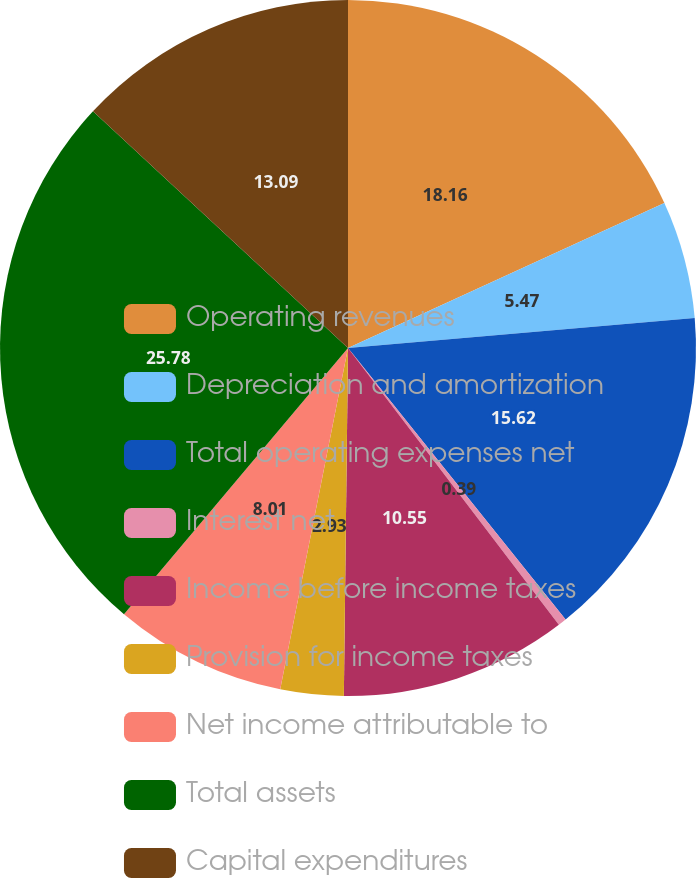Convert chart. <chart><loc_0><loc_0><loc_500><loc_500><pie_chart><fcel>Operating revenues<fcel>Depreciation and amortization<fcel>Total operating expenses net<fcel>Interest net<fcel>Income before income taxes<fcel>Provision for income taxes<fcel>Net income attributable to<fcel>Total assets<fcel>Capital expenditures<nl><fcel>18.16%<fcel>5.47%<fcel>15.62%<fcel>0.39%<fcel>10.55%<fcel>2.93%<fcel>8.01%<fcel>25.78%<fcel>13.09%<nl></chart> 